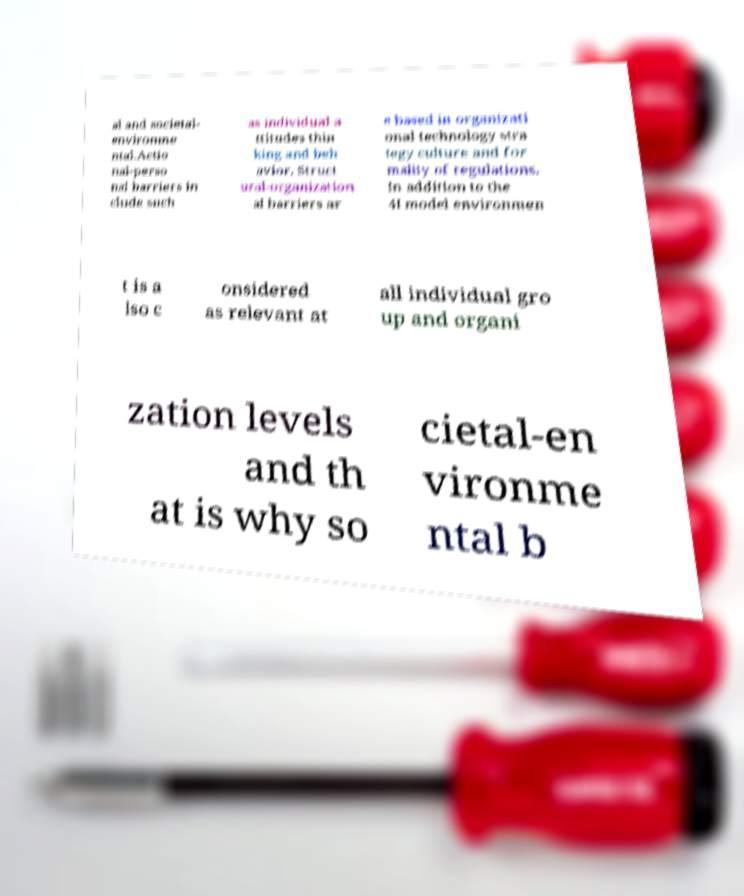For documentation purposes, I need the text within this image transcribed. Could you provide that? al and societal- environme ntal.Actio nal-perso nal barriers in clude such as individual a ttitudes thin king and beh avior. Struct ural-organization al barriers ar e based in organizati onal technology stra tegy culture and for mality of regulations. In addition to the 4I model environmen t is a lso c onsidered as relevant at all individual gro up and organi zation levels and th at is why so cietal-en vironme ntal b 